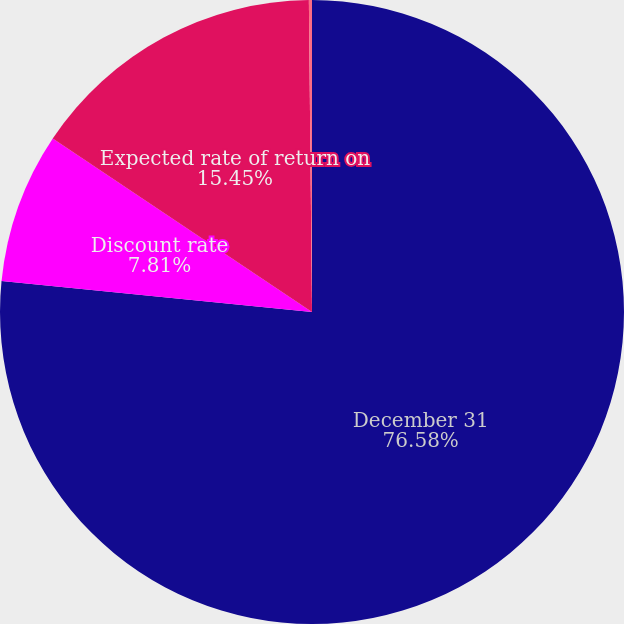<chart> <loc_0><loc_0><loc_500><loc_500><pie_chart><fcel>December 31<fcel>Discount rate<fcel>Expected rate of return on<fcel>Salary growth rate<nl><fcel>76.58%<fcel>7.81%<fcel>15.45%<fcel>0.16%<nl></chart> 